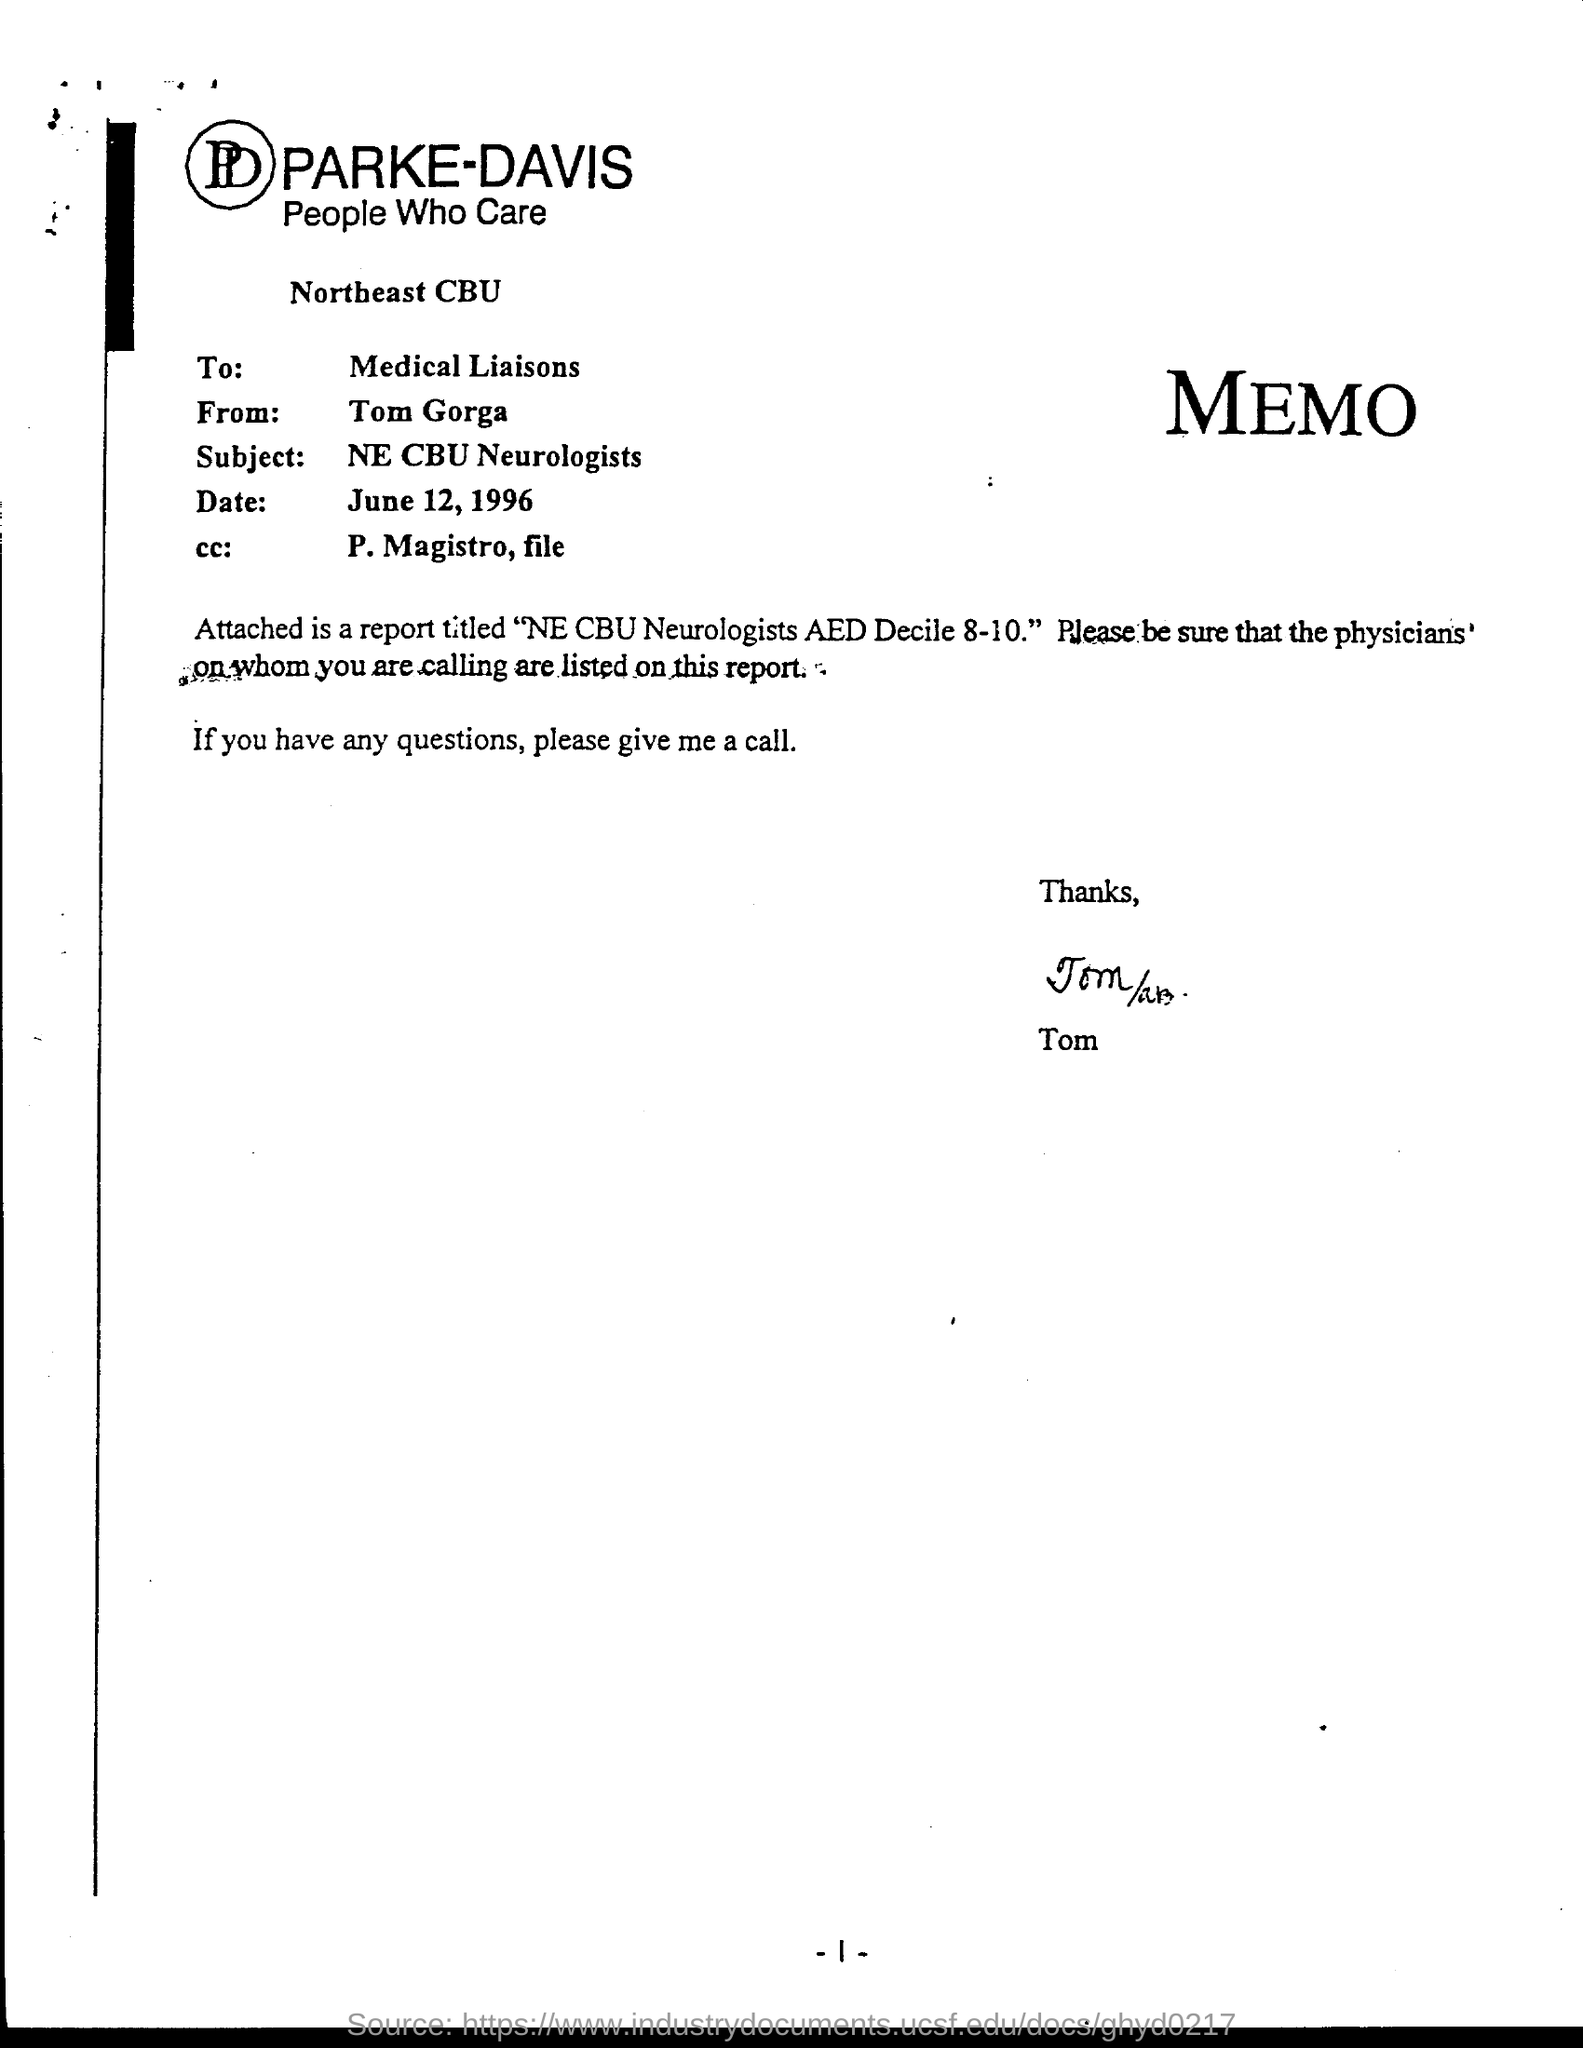List a handful of essential elements in this visual. The subject of the sentence is "What is the subject? The date is June 12, 1996. The memo is from Tom Gorga. The cc: field is for the name of the person to whom the email should be sent. The value for the cc: field in this email is 'P. Magistro, file...' The page number is -1- through -1-. 